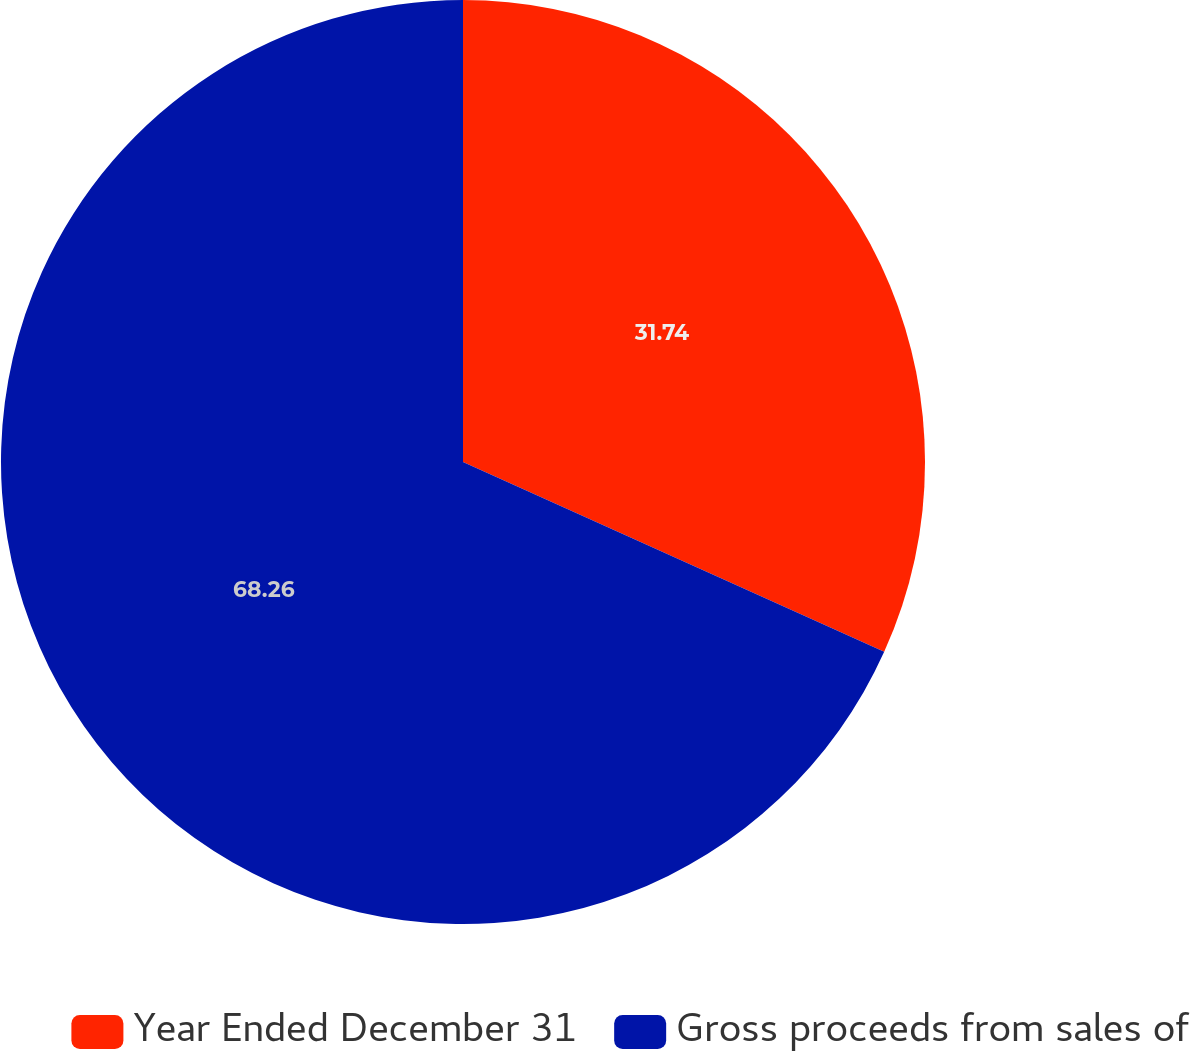Convert chart. <chart><loc_0><loc_0><loc_500><loc_500><pie_chart><fcel>Year Ended December 31<fcel>Gross proceeds from sales of<nl><fcel>31.74%<fcel>68.26%<nl></chart> 